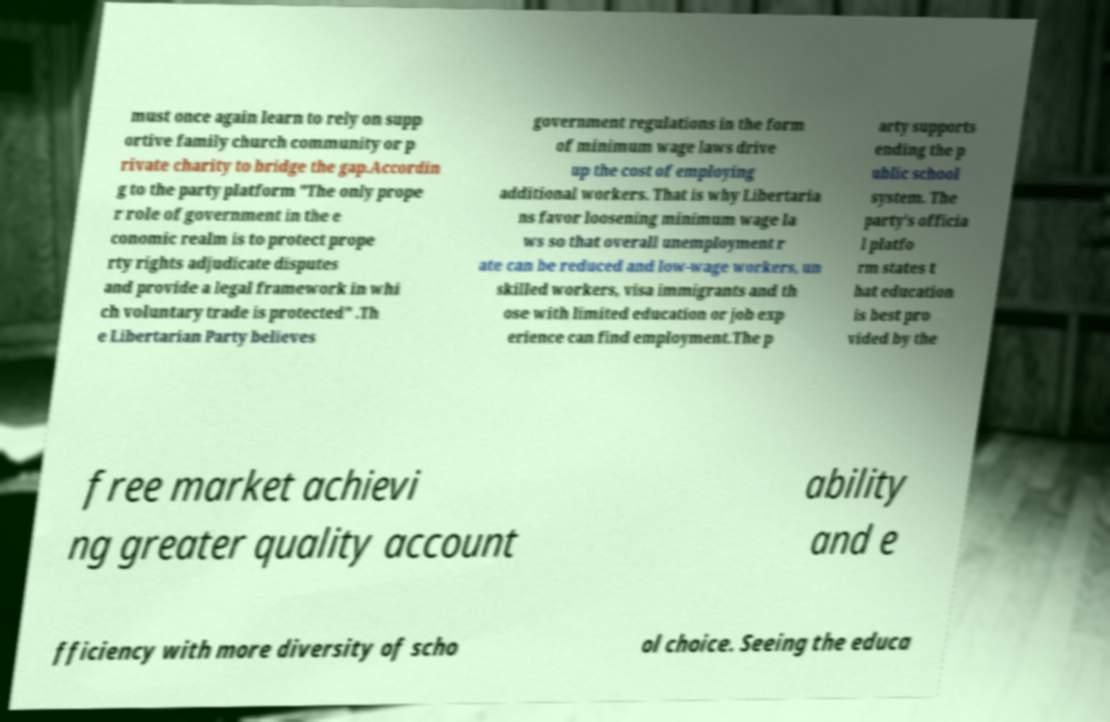For documentation purposes, I need the text within this image transcribed. Could you provide that? must once again learn to rely on supp ortive family church community or p rivate charity to bridge the gap.Accordin g to the party platform "The only prope r role of government in the e conomic realm is to protect prope rty rights adjudicate disputes and provide a legal framework in whi ch voluntary trade is protected" .Th e Libertarian Party believes government regulations in the form of minimum wage laws drive up the cost of employing additional workers. That is why Libertaria ns favor loosening minimum wage la ws so that overall unemployment r ate can be reduced and low-wage workers, un skilled workers, visa immigrants and th ose with limited education or job exp erience can find employment.The p arty supports ending the p ublic school system. The party's officia l platfo rm states t hat education is best pro vided by the free market achievi ng greater quality account ability and e fficiency with more diversity of scho ol choice. Seeing the educa 